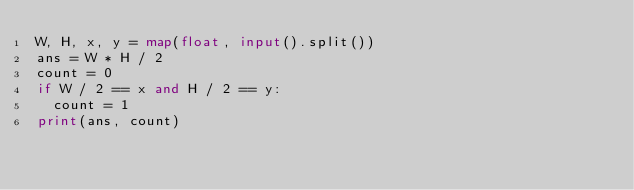<code> <loc_0><loc_0><loc_500><loc_500><_Python_>W, H, x, y = map(float, input().split())
ans = W * H / 2
count = 0
if W / 2 == x and H / 2 == y:
  count = 1
print(ans, count)</code> 